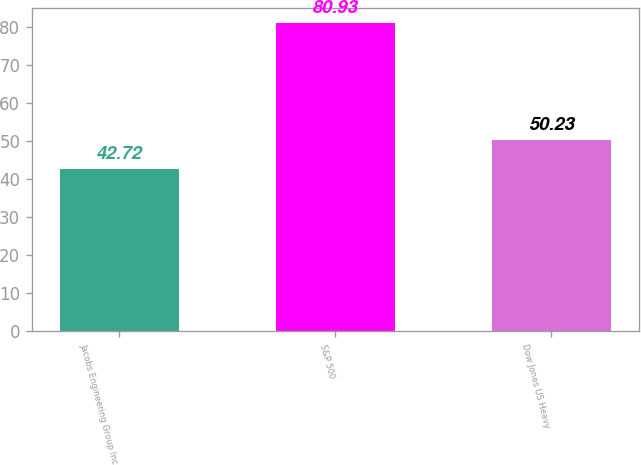Convert chart. <chart><loc_0><loc_0><loc_500><loc_500><bar_chart><fcel>Jacobs Engineering Group Inc<fcel>S&P 500<fcel>Dow Jones US Heavy<nl><fcel>42.72<fcel>80.93<fcel>50.23<nl></chart> 